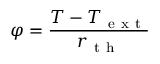<formula> <loc_0><loc_0><loc_500><loc_500>\varphi = \frac { T - T _ { e x t } } { r _ { t h } }</formula> 